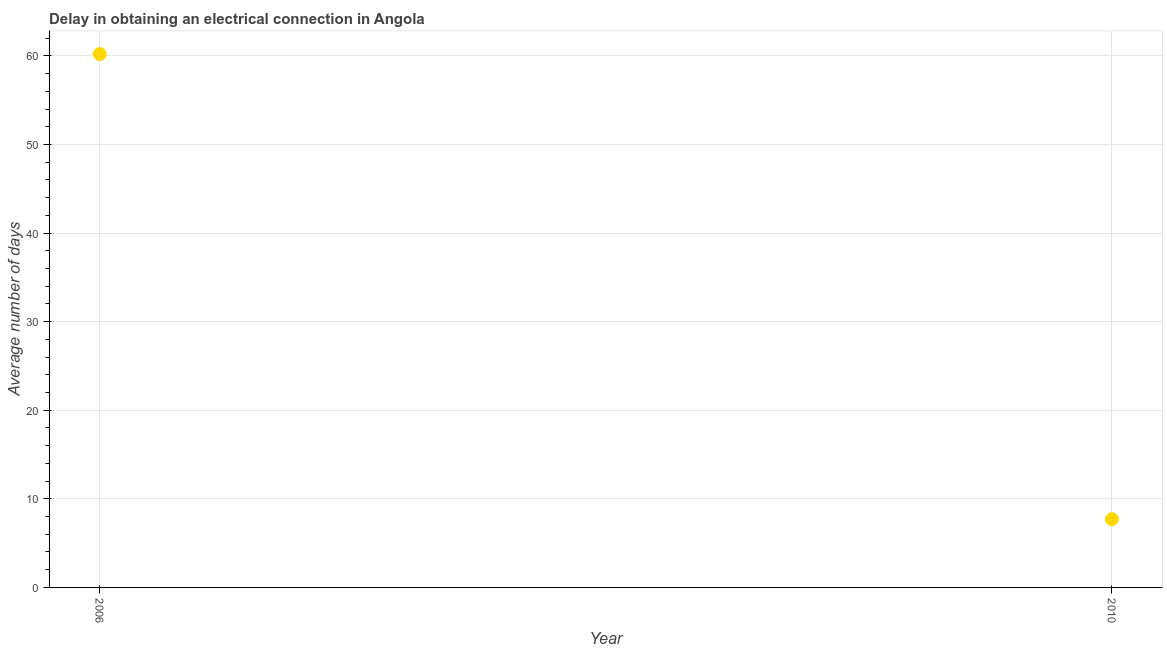Across all years, what is the maximum dalay in electrical connection?
Offer a terse response. 60.2. Across all years, what is the minimum dalay in electrical connection?
Provide a succinct answer. 7.7. In which year was the dalay in electrical connection maximum?
Ensure brevity in your answer.  2006. What is the sum of the dalay in electrical connection?
Offer a very short reply. 67.9. What is the difference between the dalay in electrical connection in 2006 and 2010?
Your answer should be compact. 52.5. What is the average dalay in electrical connection per year?
Ensure brevity in your answer.  33.95. What is the median dalay in electrical connection?
Give a very brief answer. 33.95. In how many years, is the dalay in electrical connection greater than 18 days?
Keep it short and to the point. 1. Do a majority of the years between 2006 and 2010 (inclusive) have dalay in electrical connection greater than 2 days?
Offer a very short reply. Yes. What is the ratio of the dalay in electrical connection in 2006 to that in 2010?
Provide a succinct answer. 7.82. How many dotlines are there?
Offer a very short reply. 1. How many years are there in the graph?
Provide a short and direct response. 2. Are the values on the major ticks of Y-axis written in scientific E-notation?
Give a very brief answer. No. Does the graph contain any zero values?
Offer a terse response. No. Does the graph contain grids?
Offer a very short reply. Yes. What is the title of the graph?
Your answer should be very brief. Delay in obtaining an electrical connection in Angola. What is the label or title of the X-axis?
Your response must be concise. Year. What is the label or title of the Y-axis?
Your answer should be compact. Average number of days. What is the Average number of days in 2006?
Offer a very short reply. 60.2. What is the Average number of days in 2010?
Your answer should be compact. 7.7. What is the difference between the Average number of days in 2006 and 2010?
Your answer should be very brief. 52.5. What is the ratio of the Average number of days in 2006 to that in 2010?
Provide a succinct answer. 7.82. 